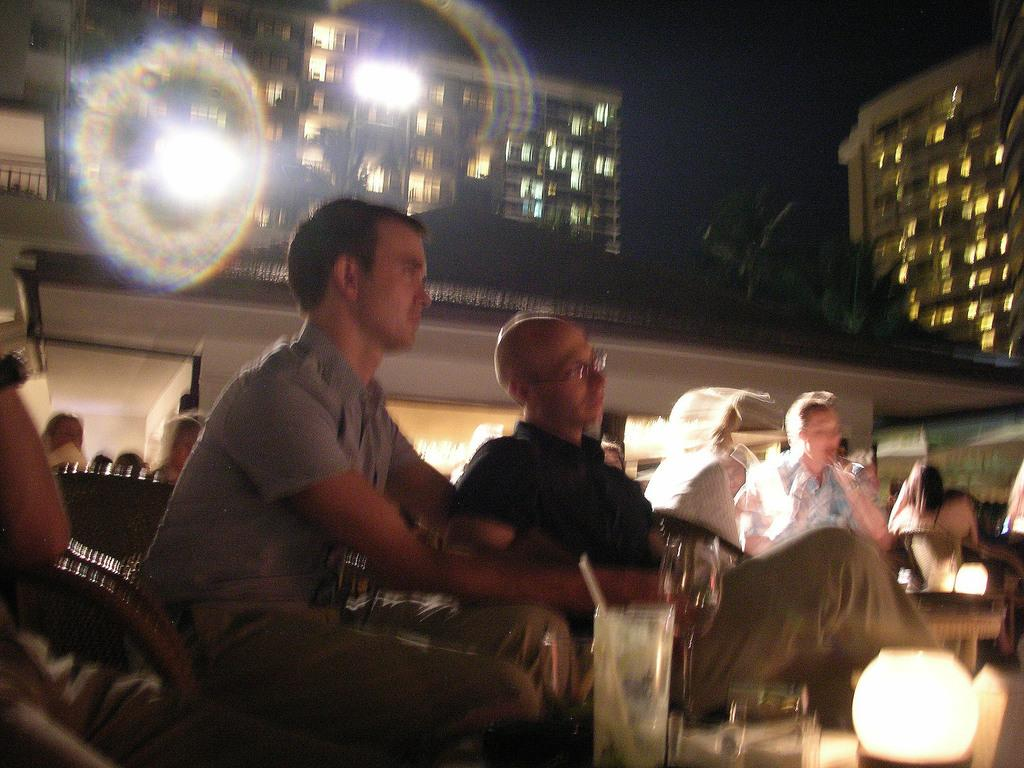What are the people in the image doing? The people in the image are sitting on chairs. What is located in the center of the image? There is a table in the image. What is on the table? A lamp, a glass, and other objects are on the table. What can be seen in the background of the image? There are buildings in the background of the image. Where is the scarecrow located in the image? There is no scarecrow present in the image. What does the dad in the image say to the people sitting on chairs? There is no dad or dialogue present in the image. 